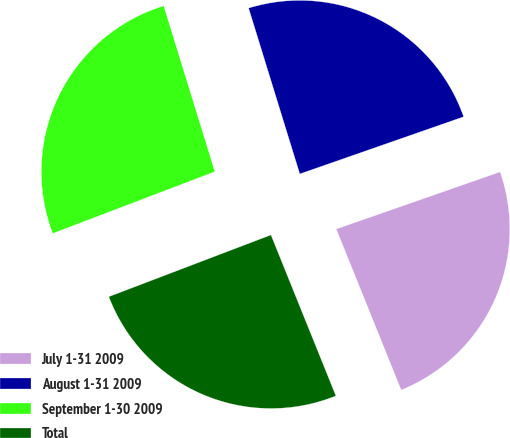Convert chart to OTSL. <chart><loc_0><loc_0><loc_500><loc_500><pie_chart><fcel>July 1-31 2009<fcel>August 1-31 2009<fcel>September 1-30 2009<fcel>Total<nl><fcel>24.24%<fcel>24.42%<fcel>26.03%<fcel>25.31%<nl></chart> 